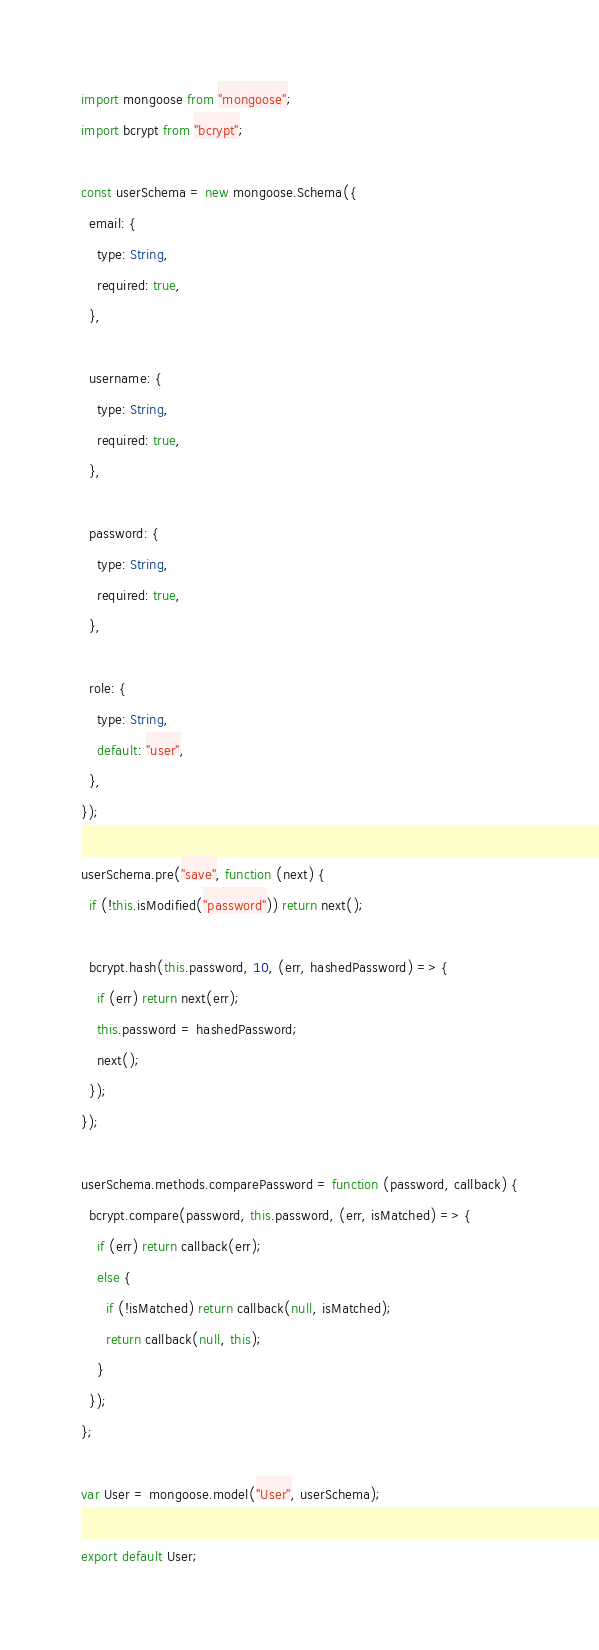Convert code to text. <code><loc_0><loc_0><loc_500><loc_500><_JavaScript_>import mongoose from "mongoose";
import bcrypt from "bcrypt";

const userSchema = new mongoose.Schema({
  email: {
    type: String,
    required: true,
  },

  username: {
    type: String,
    required: true,
  },

  password: {
    type: String,
    required: true,
  },

  role: {
    type: String,
    default: "user",
  },
});

userSchema.pre("save", function (next) {
  if (!this.isModified("password")) return next();

  bcrypt.hash(this.password, 10, (err, hashedPassword) => {
    if (err) return next(err);
    this.password = hashedPassword;
    next();
  });
});

userSchema.methods.comparePassword = function (password, callback) {
  bcrypt.compare(password, this.password, (err, isMatched) => {
    if (err) return callback(err);
    else {
      if (!isMatched) return callback(null, isMatched);
      return callback(null, this);
    }
  });
};

var User = mongoose.model("User", userSchema);

export default User;
</code> 